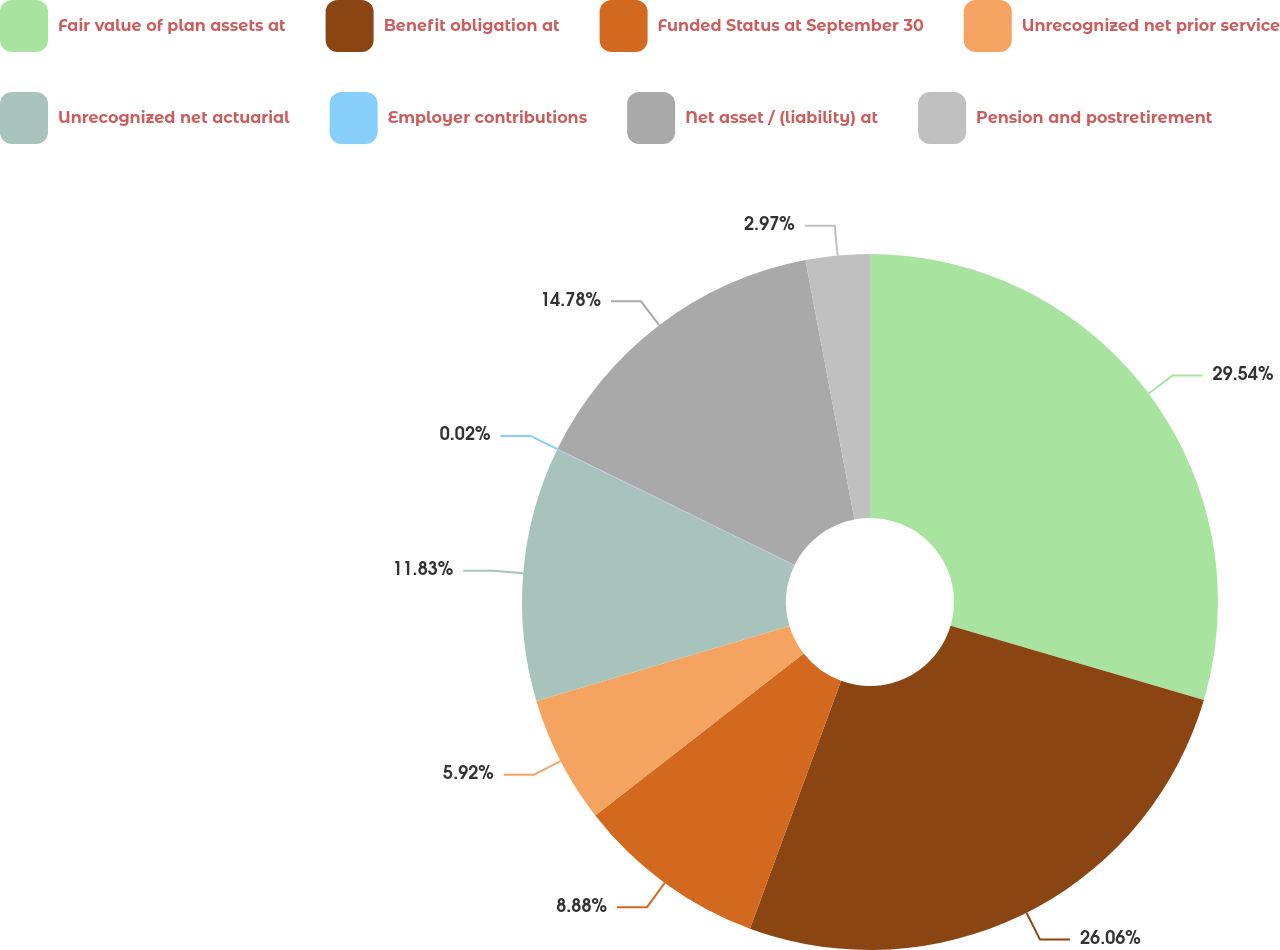Convert chart. <chart><loc_0><loc_0><loc_500><loc_500><pie_chart><fcel>Fair value of plan assets at<fcel>Benefit obligation at<fcel>Funded Status at September 30<fcel>Unrecognized net prior service<fcel>Unrecognized net actuarial<fcel>Employer contributions<fcel>Net asset / (liability) at<fcel>Pension and postretirement<nl><fcel>29.55%<fcel>26.06%<fcel>8.88%<fcel>5.92%<fcel>11.83%<fcel>0.02%<fcel>14.78%<fcel>2.97%<nl></chart> 